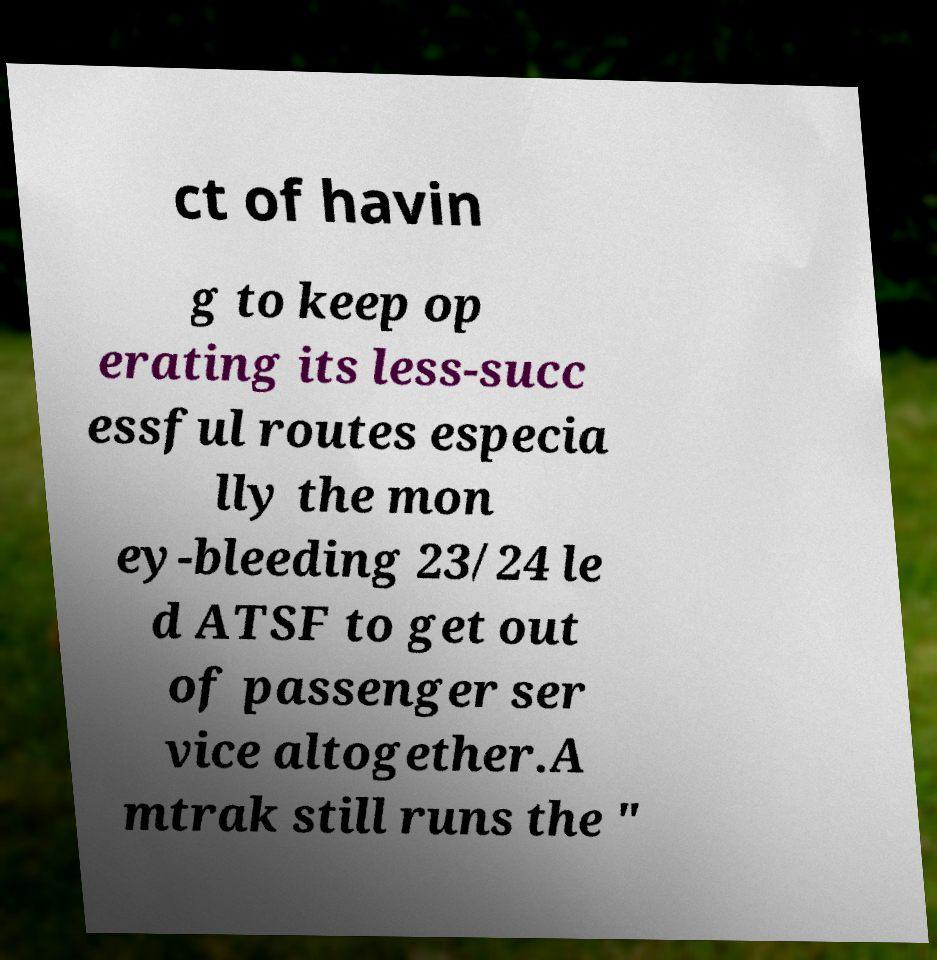Can you accurately transcribe the text from the provided image for me? ct of havin g to keep op erating its less-succ essful routes especia lly the mon ey-bleeding 23/24 le d ATSF to get out of passenger ser vice altogether.A mtrak still runs the " 